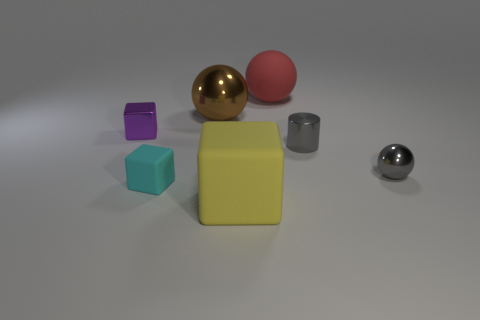The rubber thing behind the big object to the left of the yellow matte block is what shape?
Your answer should be compact. Sphere. How many brown objects are either metallic things or big rubber blocks?
Provide a short and direct response. 1. The small ball is what color?
Ensure brevity in your answer.  Gray. Does the cylinder have the same size as the rubber ball?
Your answer should be compact. No. Are there any other things that have the same shape as the small purple thing?
Give a very brief answer. Yes. Is the material of the tiny cyan cube the same as the big object on the right side of the large yellow object?
Your answer should be very brief. Yes. Is the color of the rubber thing behind the gray ball the same as the small metal cube?
Provide a succinct answer. No. What number of tiny shiny objects are left of the gray shiny cylinder and in front of the gray shiny cylinder?
Provide a short and direct response. 0. What number of other things are made of the same material as the large red ball?
Keep it short and to the point. 2. Are the sphere in front of the purple block and the yellow block made of the same material?
Offer a very short reply. No. 